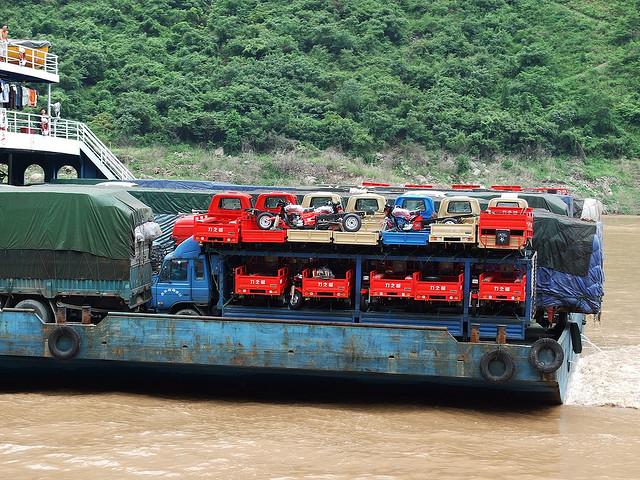What is the boat hauling?
Answer briefly. Trucks. What color is the water?
Write a very short answer. Brown. What color is the boat?
Answer briefly. Blue. 